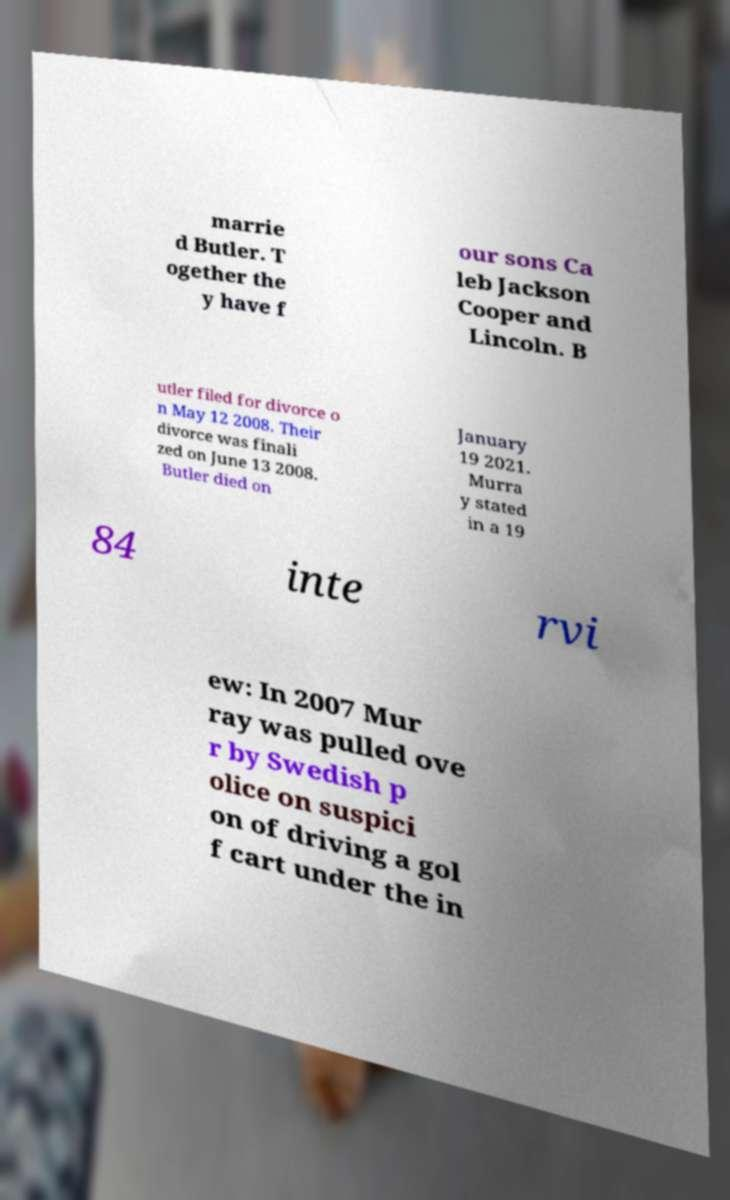Can you read and provide the text displayed in the image?This photo seems to have some interesting text. Can you extract and type it out for me? marrie d Butler. T ogether the y have f our sons Ca leb Jackson Cooper and Lincoln. B utler filed for divorce o n May 12 2008. Their divorce was finali zed on June 13 2008. Butler died on January 19 2021. Murra y stated in a 19 84 inte rvi ew: In 2007 Mur ray was pulled ove r by Swedish p olice on suspici on of driving a gol f cart under the in 